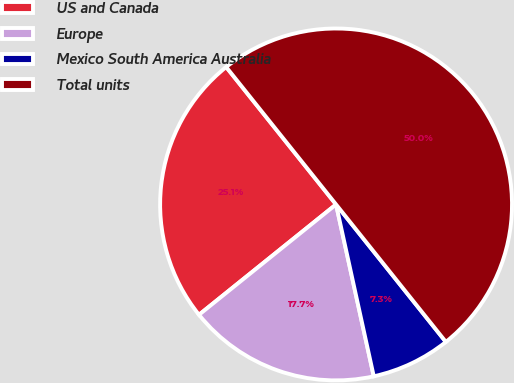<chart> <loc_0><loc_0><loc_500><loc_500><pie_chart><fcel>US and Canada<fcel>Europe<fcel>Mexico South America Australia<fcel>Total units<nl><fcel>25.05%<fcel>17.65%<fcel>7.29%<fcel>50.0%<nl></chart> 